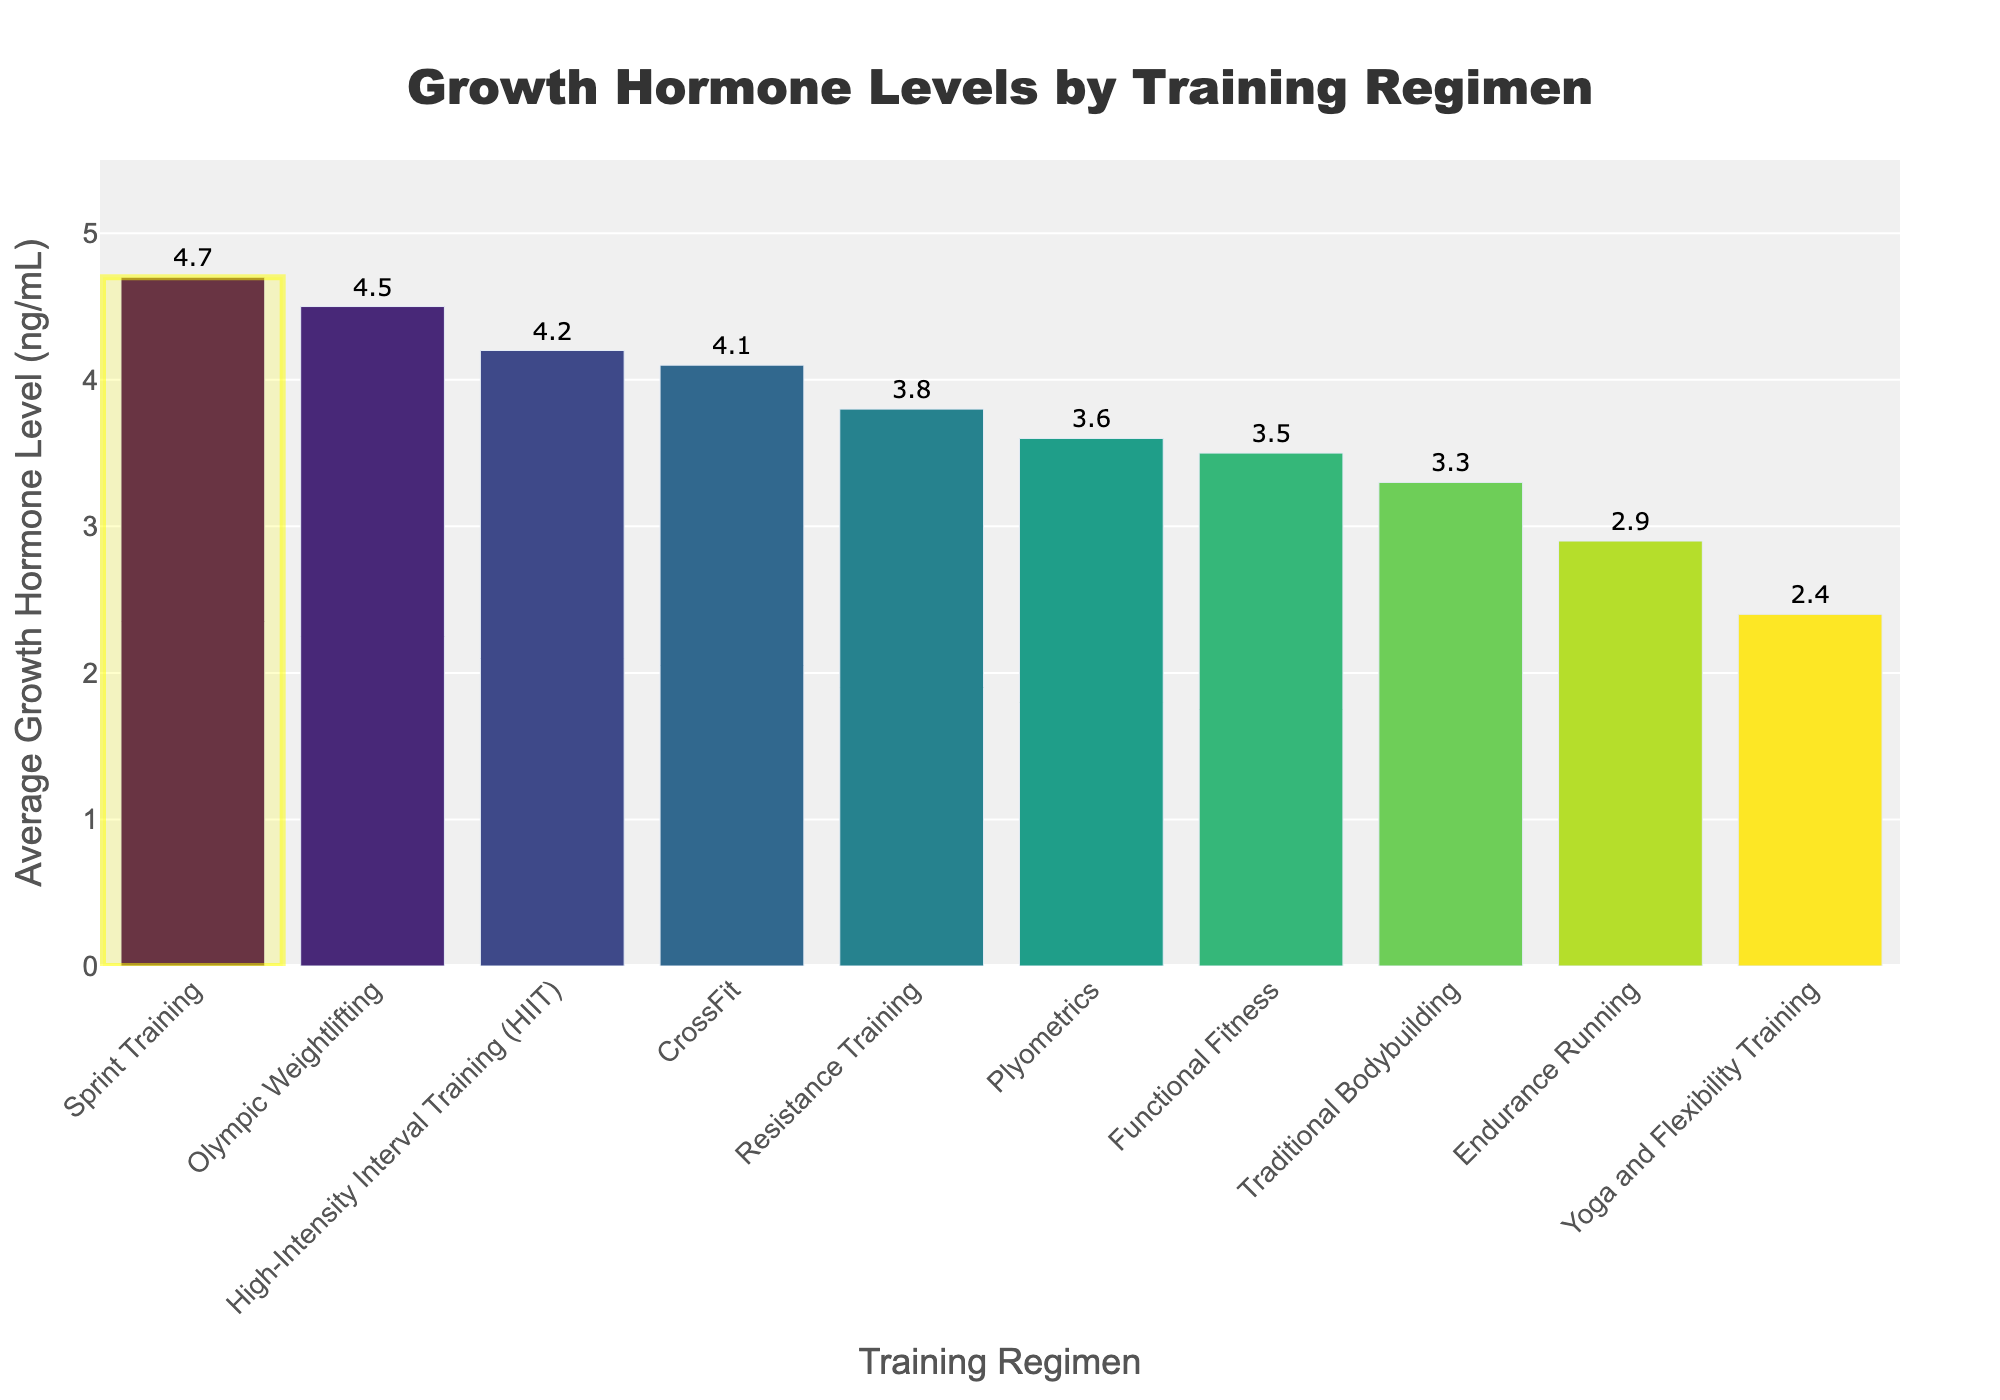What is the training regimen with the highest average growth hormone level and what is this level? The highest bar corresponds to Sprint Training, and its height gives the average growth hormone level. The level is shown as a label at the top of the bar.
Answer: Sprint Training, 4.7 ng/mL How does the average growth hormone level in Yoga and Flexibility Training compare to that in CrossFit? The height of the bar for Yoga and Flexibility Training is lower than that for CrossFit. The precise hormone levels are shown at the top of each bar: 2.4 ng/mL for Yoga and Flexibility Training and 4.1 ng/mL for CrossFit.
Answer: Yoga and Flexibility Training is 1.7 ng/mL lower than CrossFit Which training regimen has a higher growth hormone level: Endurance Running or Plyometrics? By comparing the heights of the bars and their labels, Plyometrics (3.6 ng/mL) has a higher level than Endurance Running (2.9 ng/mL).
Answer: Plyometrics What is the average growth hormone level among all the training regimens? To find the average, sum all the hormone levels and divide by the number of regimens. The levels are: 4.2, 3.8, 2.9, 4.5, 4.1, 3.6, 3.3, 3.5, 2.4, 4.7. The sum is 37 and there are 10 regimens. Thus, the average is 37/10.
Answer: 3.7 ng/mL Which training regimens fall below the average growth hormone level found in question 4? Regimens with bars shorter than the average (3.7 ng/mL) are Endurance Running (2.9), Yoga and Flexibility Training (2.4), Traditional Bodybuilding (3.3), Functional Fitness (3.5), and Plyometrics (3.6).
Answer: Endurance Running, Yoga and Flexibility Training, Traditional Bodybuilding, Functional Fitness, Plyometrics What's the difference between the highest and lowest growth hormone levels recorded in the chart? The highest level is 4.7 ng/mL in Sprint Training, and the lowest is 2.4 ng/mL in Yoga and Flexibility Training. The difference is 4.7 - 2.4.
Answer: 2.3 ng/mL Rank the top three training regimens by their average growth hormone levels. By looking at the heights and labels of the bars, the top three are Sprint Training (4.7), Olympic Weightlifting (4.5), and High-Intensity Interval Training (4.2).
Answer: Sprint Training, Olympic Weightlifting, High-Intensity Interval Training What percentage of training regimens have an average growth hormone level of 4 ng/mL or higher? There are 10 regimens in total. Sprint Training (4.7), Olympic Weightlifting (4.5), High-Intensity Interval Training (4.2), and CrossFit (4.1) are at or above 4 ng/mL. This makes 4 out of 10 regimens. The percentage is (4/10)*100.
Answer: 40% Which training regimen has an average growth hormone level closest to 3.5 ng/mL? By comparing the bar heights and labels around 3.5 ng/mL, Functional Fitness with 3.5 ng/mL exactly fits this requirement.
Answer: Functional Fitness 